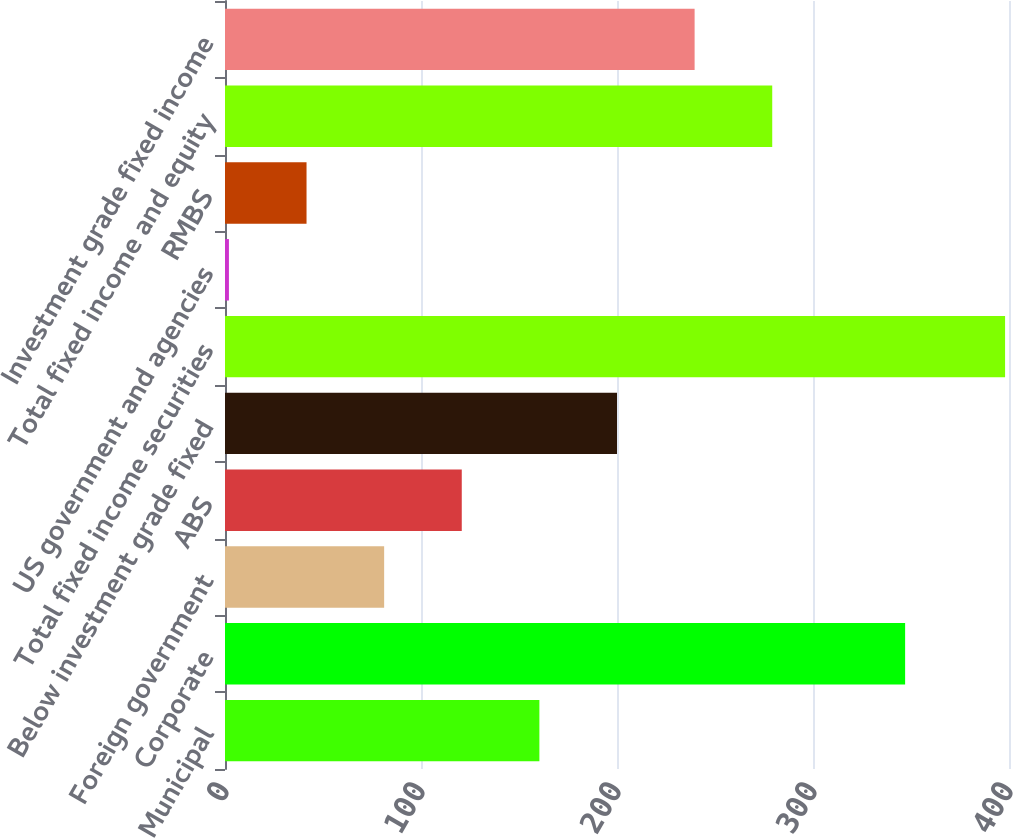Convert chart to OTSL. <chart><loc_0><loc_0><loc_500><loc_500><bar_chart><fcel>Municipal<fcel>Corporate<fcel>Foreign government<fcel>ABS<fcel>Below investment grade fixed<fcel>Total fixed income securities<fcel>US government and agencies<fcel>RMBS<fcel>Total fixed income and equity<fcel>Investment grade fixed income<nl><fcel>160.4<fcel>347<fcel>81.2<fcel>120.8<fcel>200<fcel>398<fcel>2<fcel>41.6<fcel>279.2<fcel>239.6<nl></chart> 